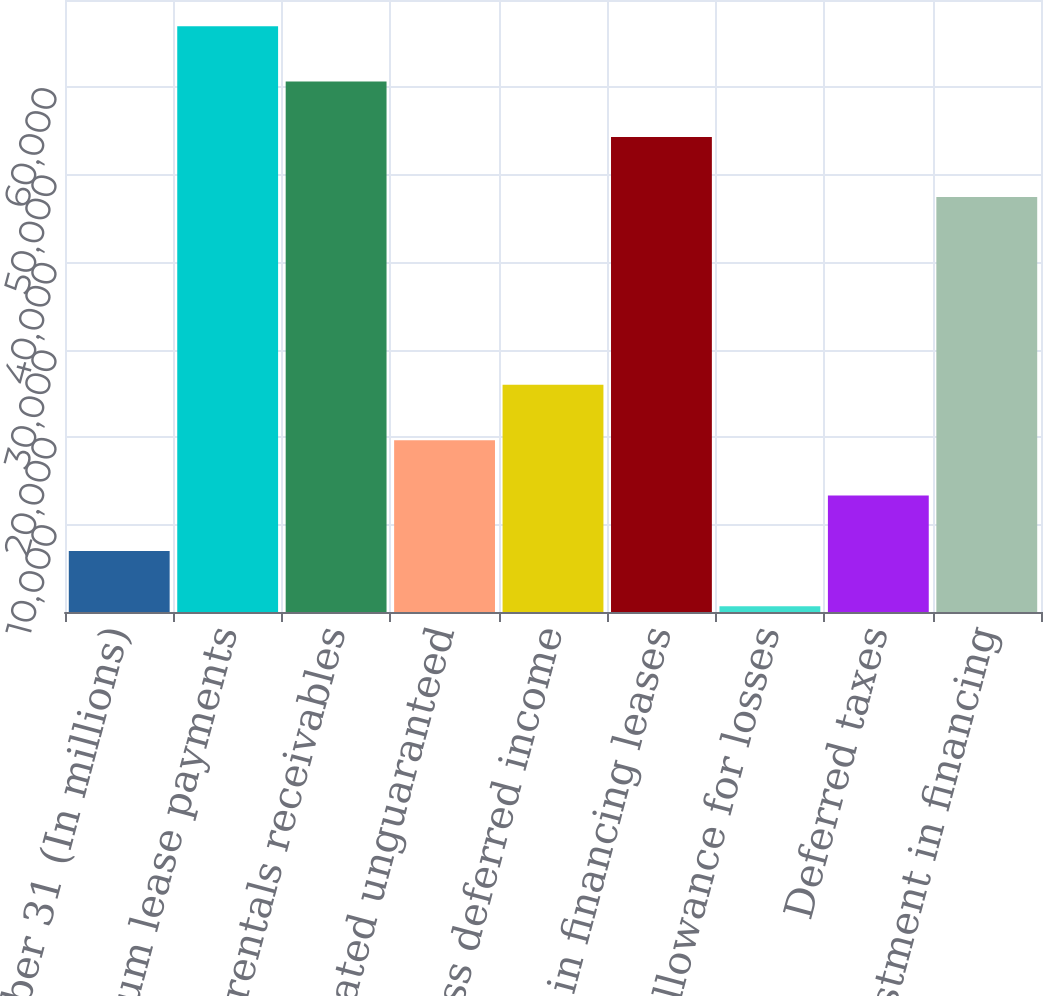<chart> <loc_0><loc_0><loc_500><loc_500><bar_chart><fcel>December 31 (In millions)<fcel>Total minimum lease payments<fcel>Net rentals receivables<fcel>Estimated unguaranteed<fcel>Less deferred income<fcel>Investment in financing leases<fcel>Allowance for losses<fcel>Deferred taxes<fcel>Net investment in financing<nl><fcel>6988.3<fcel>67000.6<fcel>60666.3<fcel>19656.9<fcel>25991.2<fcel>54332<fcel>654<fcel>13322.6<fcel>47468<nl></chart> 